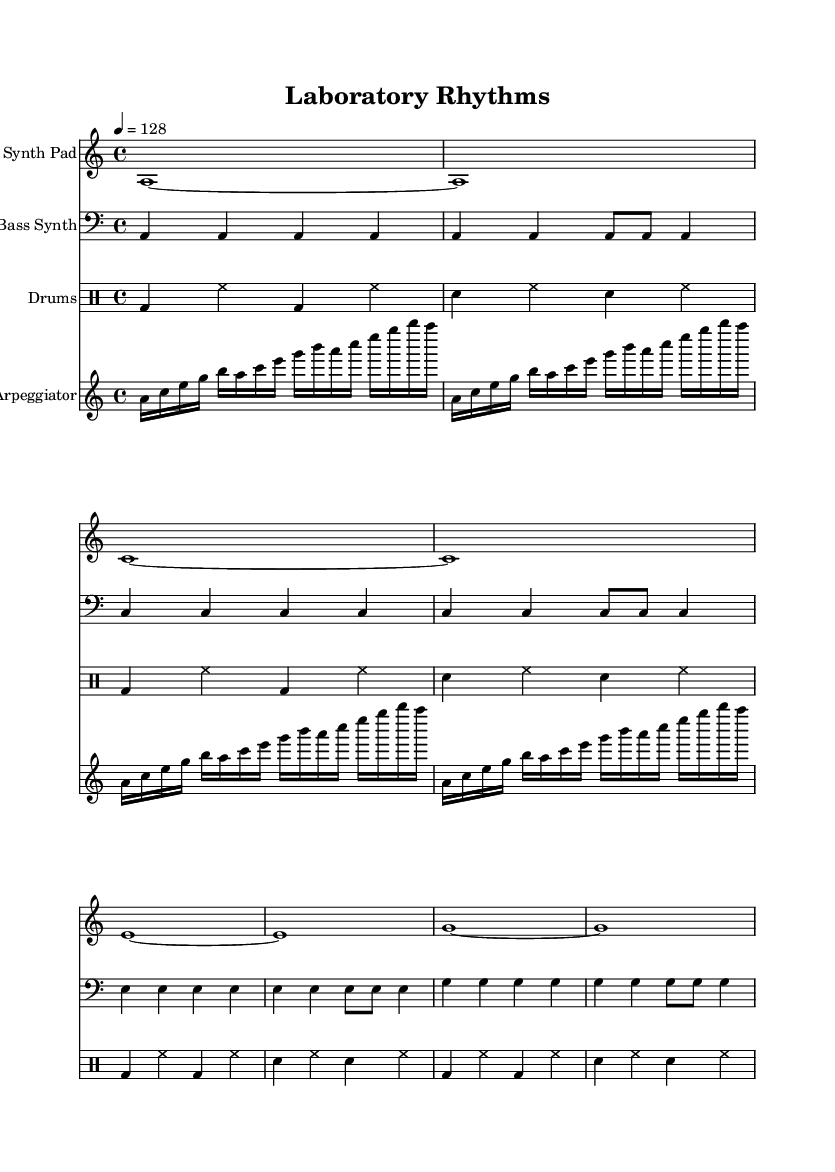What is the key signature of this music? The key signature is A minor, indicated by the absence of sharps or flats on the staff.
Answer: A minor What is the time signature of this piece? The time signature is 4/4, which is indicated at the beginning of the score where it specifies four beats per measure.
Answer: 4/4 What is the tempo marking of this composition? The tempo marking indicates that the piece should be played at 128 beats per minute. It is shown as a numerical indication (4 = 128) at the start of the score.
Answer: 128 How many measures are in the "Synth Pad" part? The "Synth Pad" part consists of 8 measures, as can be counted from the notation in the provided score; each set of bars indicates one measure.
Answer: 8 What rhythmic pattern is used in the "DrumKit" section? The "DrumKit" section exhibits a steady alternating pattern between bass drum and snare drum with hi-hat played in between, which gives it a typical house music structure.
Answer: Alternating bass and snare with hi-hat Which instruments are included in the score? The score features four instruments: Synth Pad, Bass Synth, Drums, and Arpeggiator, as specified in the staff names at the beginning of each section.
Answer: Synth Pad, Bass Synth, Drums, Arpeggiator What is the primary genre of this composition? This composition fits into the genre of Atmospheric House music, characterized by its ambient sounds and rhythmic elements that create a soothing and immersive experience.
Answer: Atmospheric House 